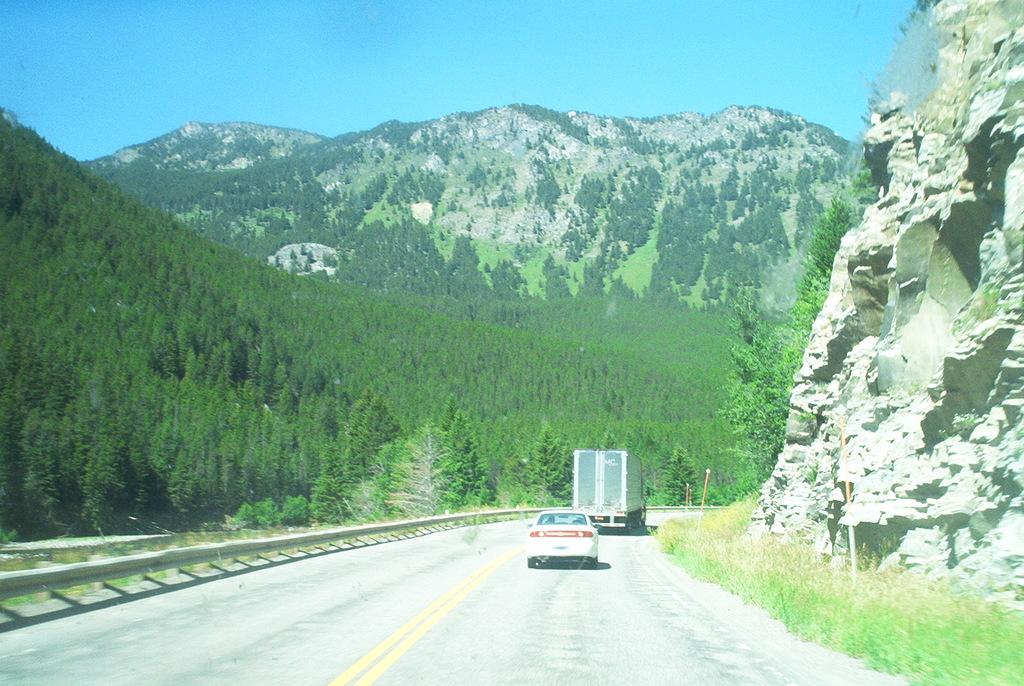How many vehicles can be seen in the image? There are two vehicles in the image. What are the vehicles doing in the image? The vehicles are passing on a motorway. What can be seen on either side of the road? There are trees on either side of the road. What type of landscape feature is visible in the background? There are mountains visible in the image. What type of grass is growing on the sofa in the image? There is no sofa or grass present in the image. Can you describe the taste of the berries in the image? There are no berries present in the image. 